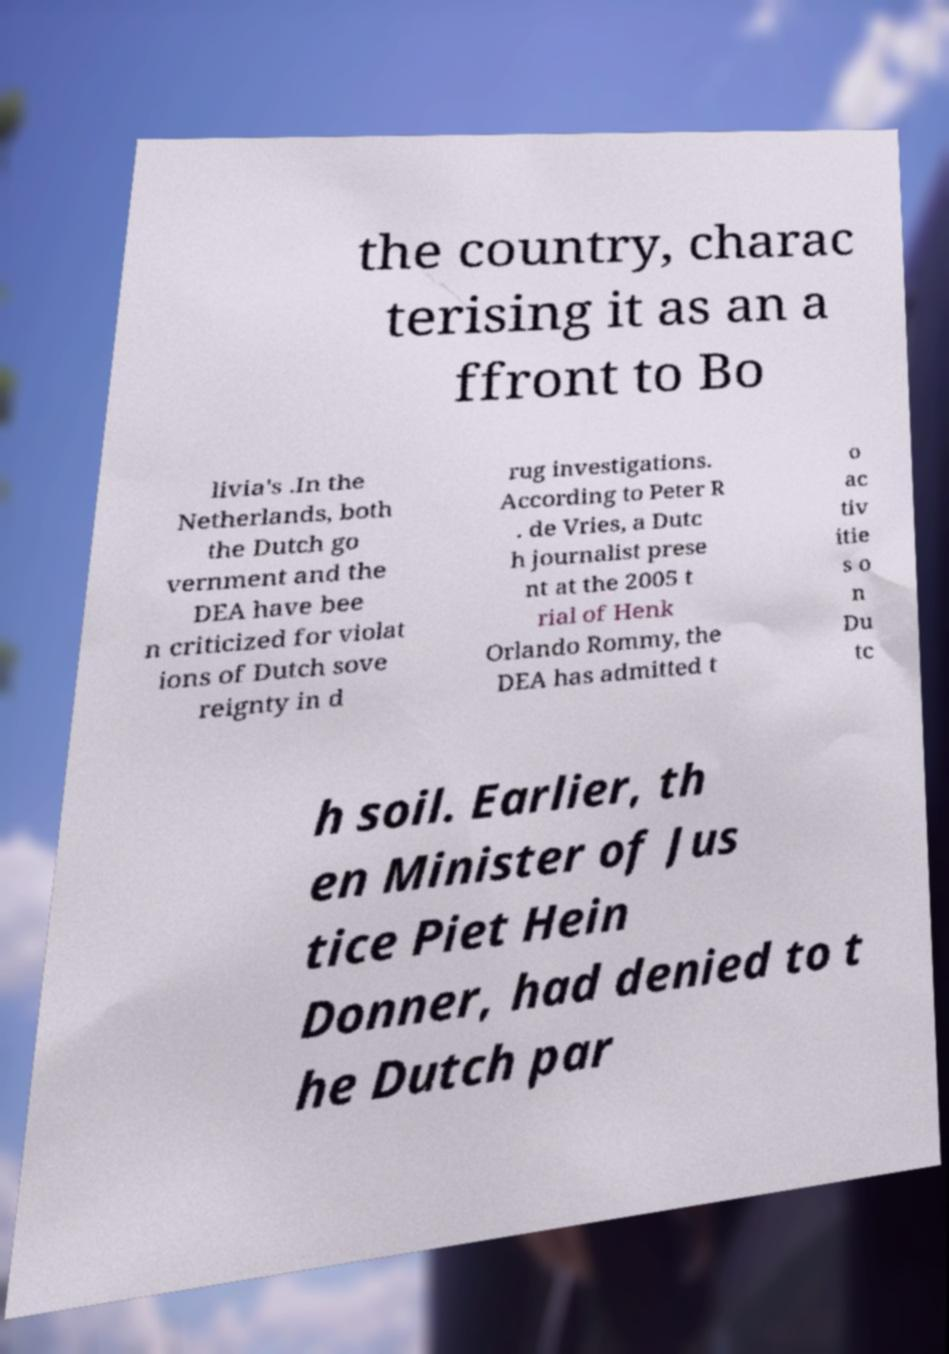Can you read and provide the text displayed in the image?This photo seems to have some interesting text. Can you extract and type it out for me? the country, charac terising it as an a ffront to Bo livia's .In the Netherlands, both the Dutch go vernment and the DEA have bee n criticized for violat ions of Dutch sove reignty in d rug investigations. According to Peter R . de Vries, a Dutc h journalist prese nt at the 2005 t rial of Henk Orlando Rommy, the DEA has admitted t o ac tiv itie s o n Du tc h soil. Earlier, th en Minister of Jus tice Piet Hein Donner, had denied to t he Dutch par 